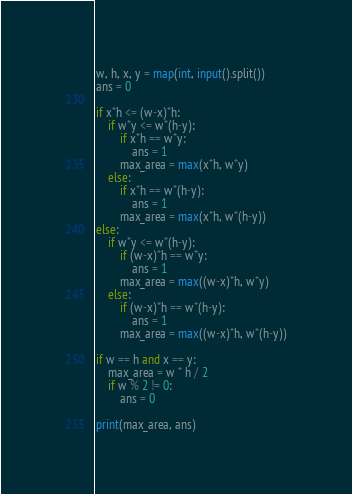Convert code to text. <code><loc_0><loc_0><loc_500><loc_500><_Python_>w, h, x, y = map(int, input().split())
ans = 0

if x*h <= (w-x)*h:
    if w*y <= w*(h-y):
        if x*h == w*y:
            ans = 1
        max_area = max(x*h, w*y)
    else:
        if x*h == w*(h-y):
            ans = 1
        max_area = max(x*h, w*(h-y))
else:
    if w*y <= w*(h-y):
        if (w-x)*h == w*y:
            ans = 1
        max_area = max((w-x)*h, w*y)
    else:
        if (w-x)*h == w*(h-y):
            ans = 1
        max_area = max((w-x)*h, w*(h-y))

if w == h and x == y:
    max_area = w * h / 2
    if w % 2 != 0:
        ans = 0

print(max_area, ans)</code> 